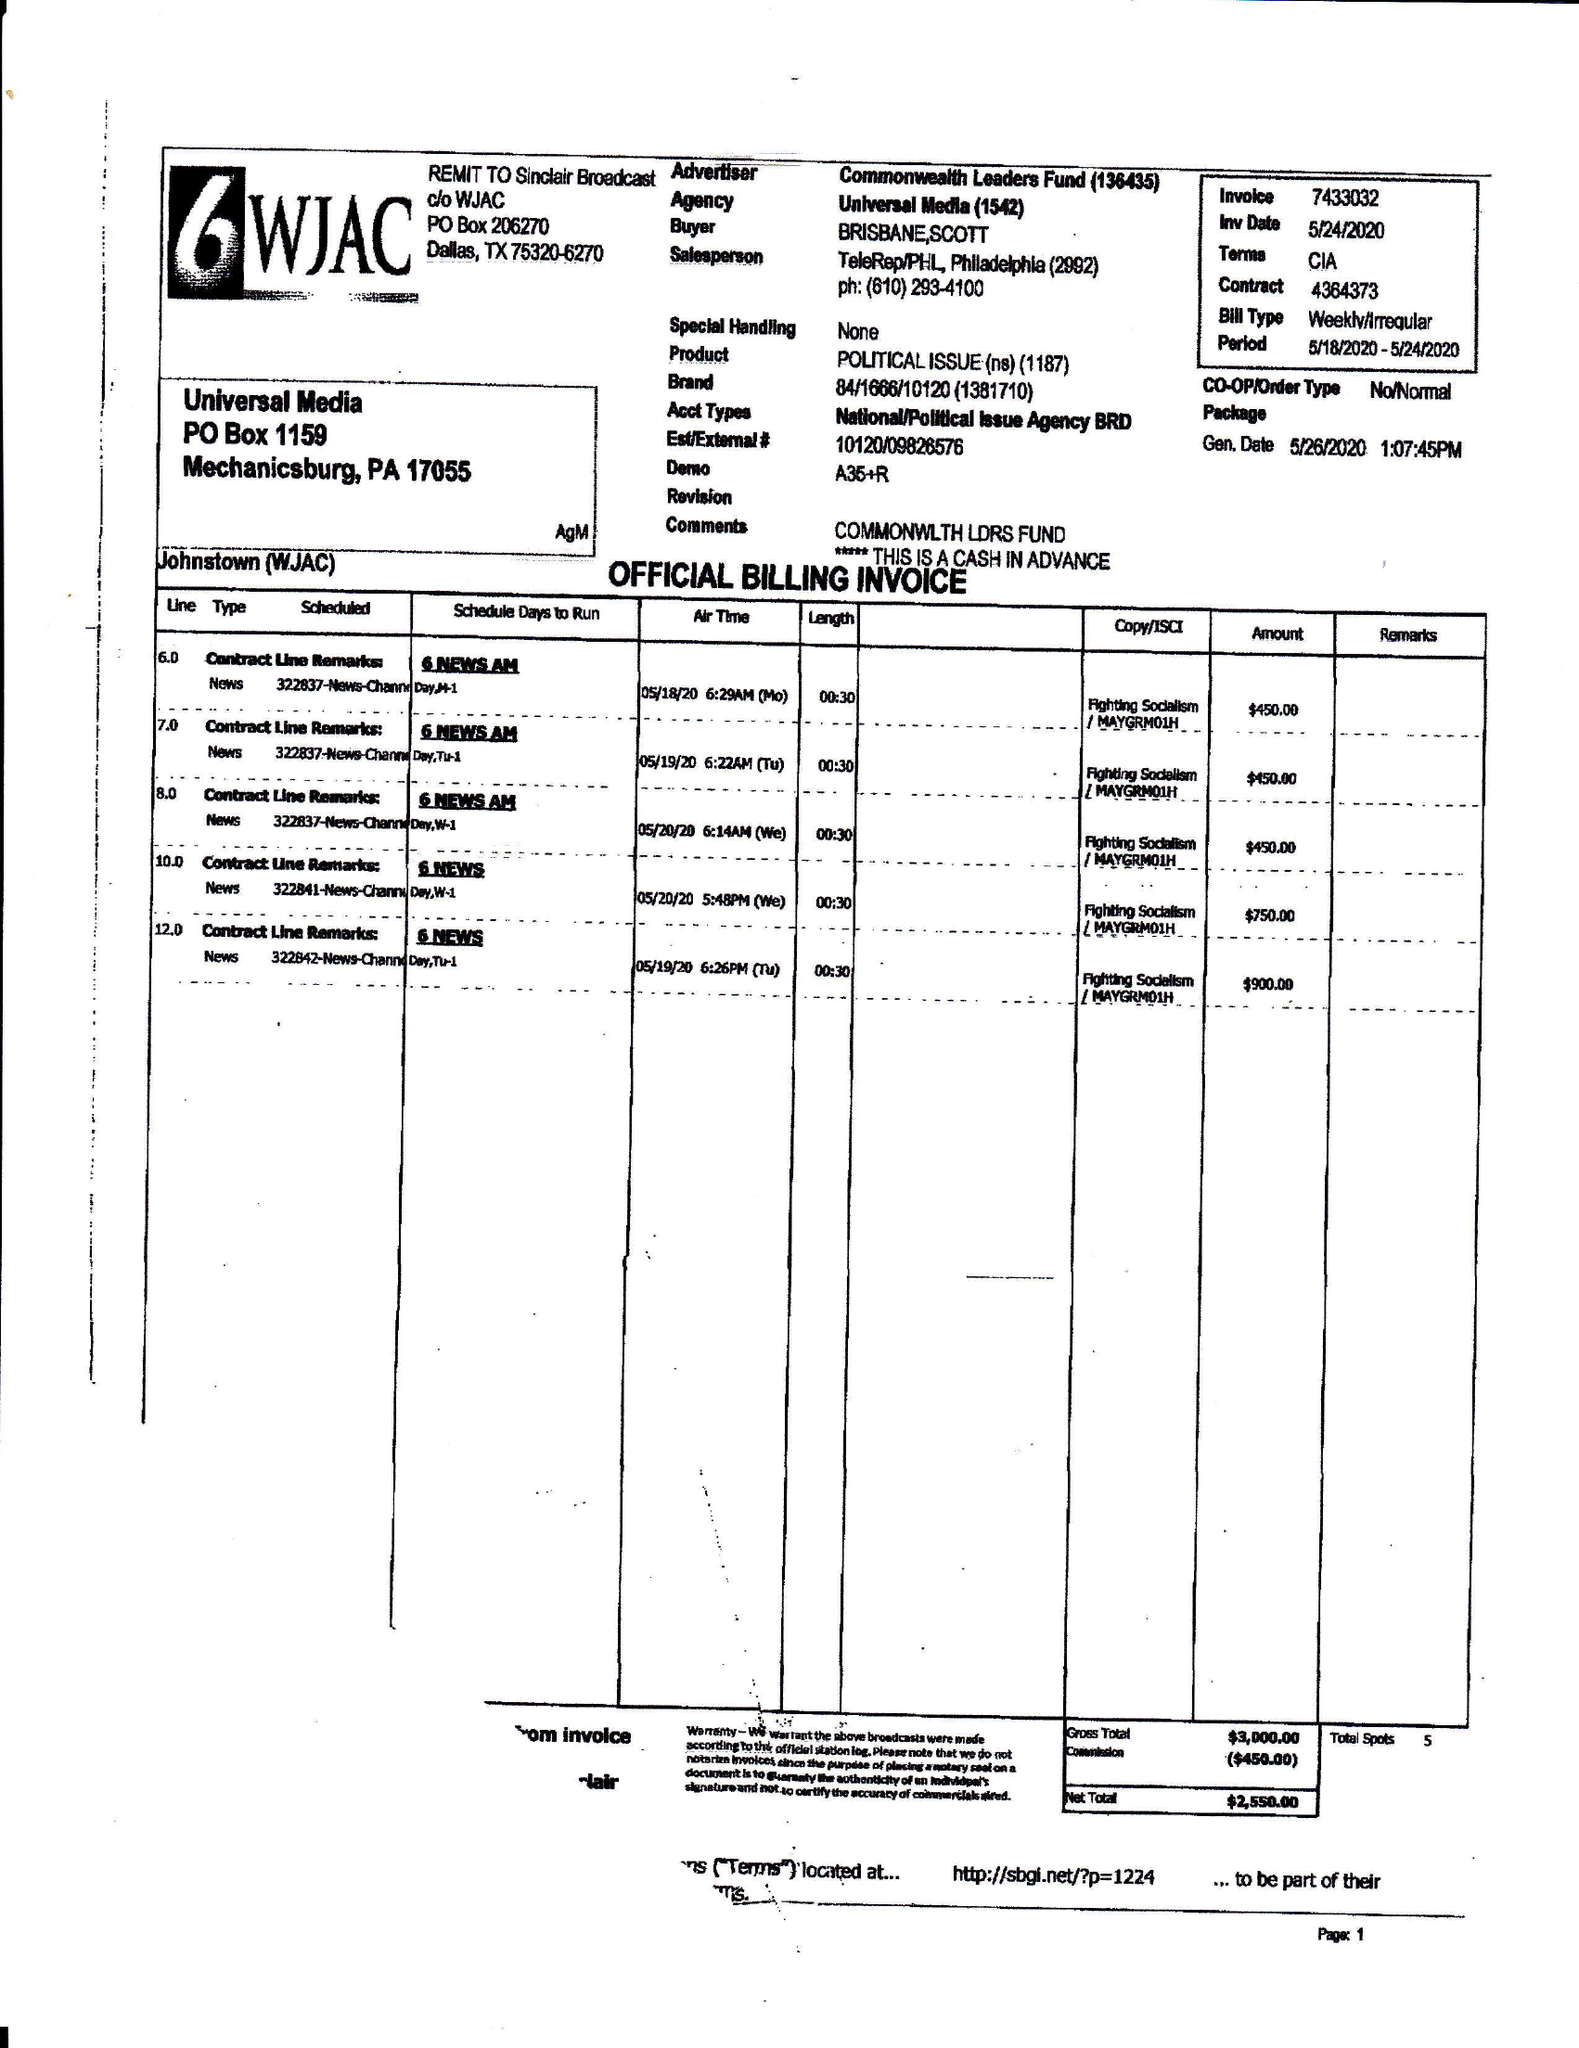What is the value for the gross_amount?
Answer the question using a single word or phrase. 3000.00 